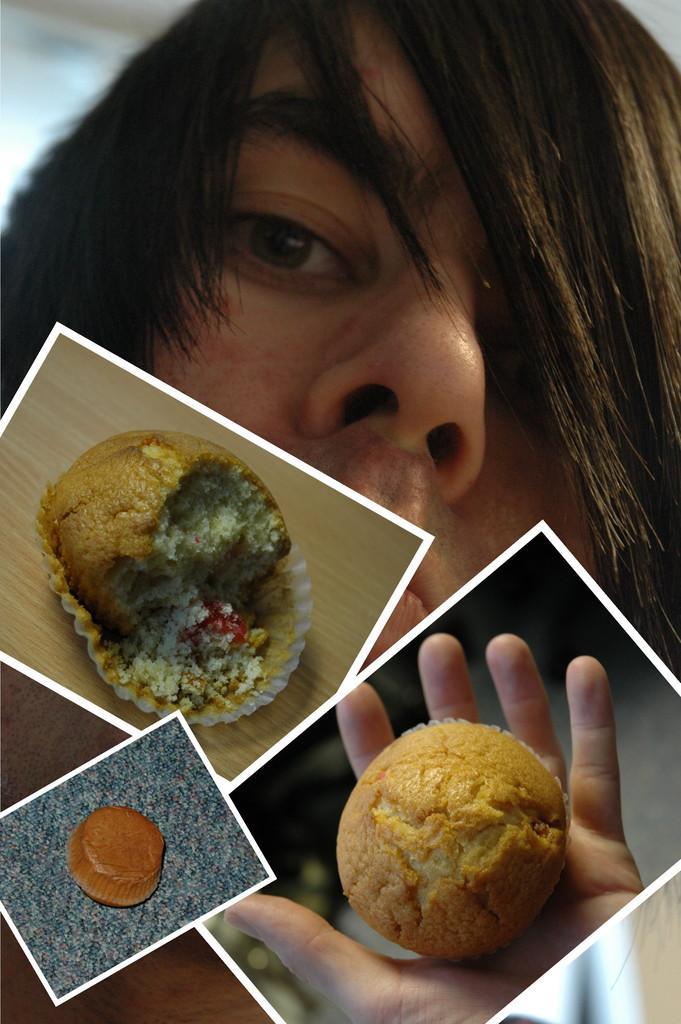Describe this image in one or two sentences. In this image there is a picture of a person and pictures of food items. 